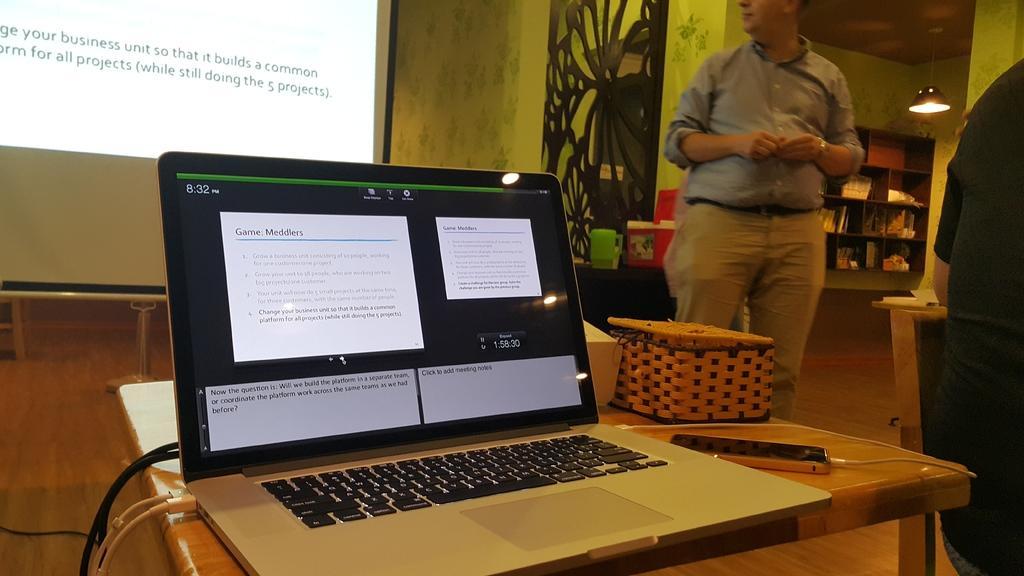Describe this image in one or two sentences. In this image I can see a laptop, a phone and a projector's screen. Here I can see few people are standing. 